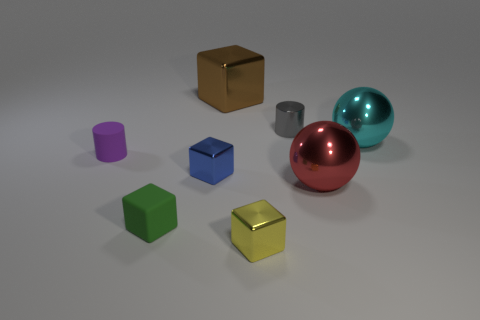The tiny matte cube has what color?
Make the answer very short. Green. Is the brown metallic cube the same size as the blue thing?
Your answer should be very brief. No. How many objects are small brown metallic blocks or large brown metallic blocks?
Offer a very short reply. 1. Is the number of tiny yellow blocks that are behind the tiny blue thing the same as the number of big red cylinders?
Provide a short and direct response. Yes. There is a tiny cylinder that is behind the tiny cylinder to the left of the green rubber thing; are there any objects that are behind it?
Ensure brevity in your answer.  Yes. What color is the other large sphere that is made of the same material as the cyan ball?
Your answer should be compact. Red. What number of cylinders are either purple matte objects or blue objects?
Keep it short and to the point. 1. There is a sphere that is behind the small matte cylinder in front of the large thing that is behind the small metal cylinder; how big is it?
Your answer should be compact. Large. What shape is the cyan object that is the same size as the brown thing?
Your response must be concise. Sphere. The blue thing has what shape?
Make the answer very short. Cube. 